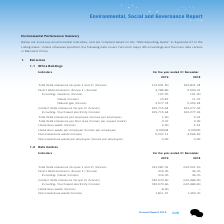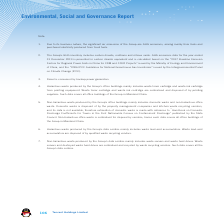According to Tencent's financial document, Where does the Group's significant air emissions arise from? fuels and purchased electricity produced from fossil fuel. The document states: "f the Group are GHG emissions, arising mainly from fuels and purchased electricity produced from fossil fuels...." Also, What does the Group's GHG inventory include? carbon dioxide, methane and nitrous oxide. The document states: "2. The Group’s GHG inventory includes carbon dioxide, methane and nitrous oxide. GHG emissions data for the year ended..." Also, What does the hazardous waste produced by the Group's office buildings mainly include? waste toner cartridge and waste ink cartridge from printing equipment. The document states: "d by the Group’s office buildings mainly includes waste toner cartridge and waste ink cartridge from printing equipment. Waste toner cartridge and was..." Also, can you calculate: What is the change between 2018 and 2019 Total GHG emissions in tonnes? Based on the calculation: 743,287.01-612,521.16, the result is 130765.85. This is based on the information: "HG emissions (Scopes 1 and 2) (tonnes) 743,287.01 612,521.16 Total GHG emissions (Scopes 1 and 2) (tonnes) 743,287.01 612,521.16..." The key data points involved are: 612,521.16, 743,287.01. Also, can you calculate: What is the change between 2018 and 2019 direct GHG emissions in tonnes? Based on the calculation: 316.35-36.76, the result is 279.59. This is based on the information: "Direct GHG emissions (Scope 1) (tonnes) 316.35 36.76 Direct GHG emissions (Scope 1) (tonnes) 316.35 36.76..." The key data points involved are: 316.35, 36.76. Also, can you calculate: What is the change between 2018 and 2019 non-hazardous waste in tonnes? Based on the calculation: 1,811.27-1,350.76, the result is 460.51. This is based on the information: "Non-hazardous waste (tonnes) 1,811.27 1,350.76 Non-hazardous waste (tonnes) 1,811.27 1,350.76..." The key data points involved are: 1,350.76, 1,811.27. 